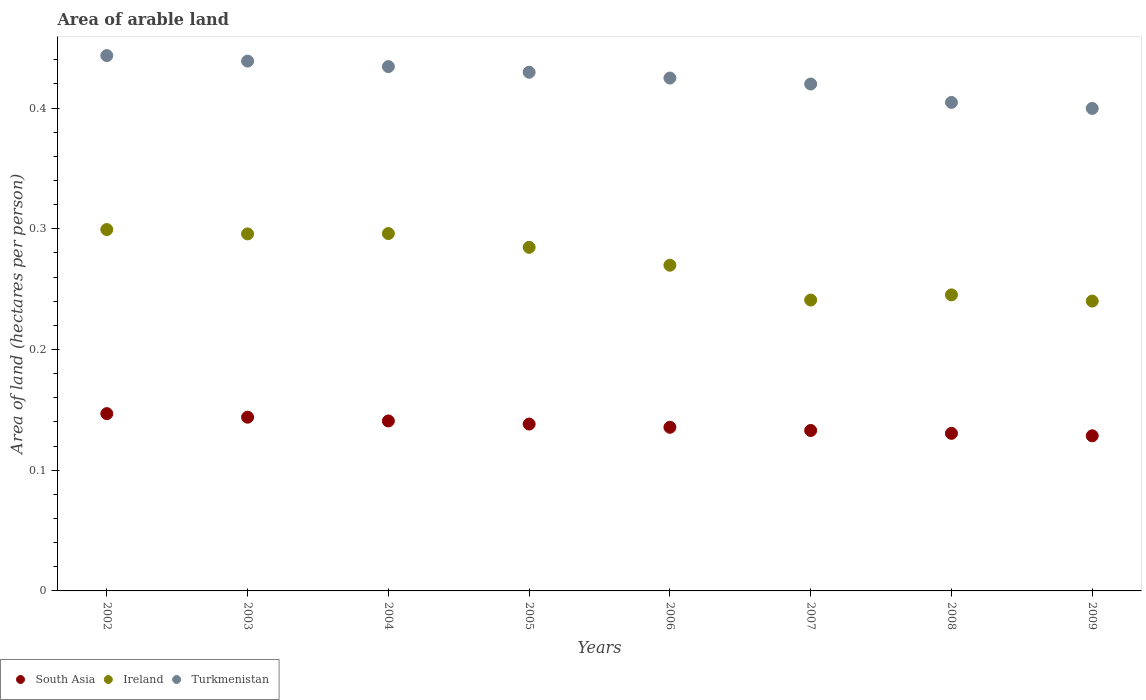What is the total arable land in Turkmenistan in 2007?
Offer a terse response. 0.42. Across all years, what is the maximum total arable land in Turkmenistan?
Offer a very short reply. 0.44. Across all years, what is the minimum total arable land in Ireland?
Give a very brief answer. 0.24. In which year was the total arable land in South Asia maximum?
Give a very brief answer. 2002. In which year was the total arable land in Turkmenistan minimum?
Provide a short and direct response. 2009. What is the total total arable land in Turkmenistan in the graph?
Give a very brief answer. 3.4. What is the difference between the total arable land in Ireland in 2004 and that in 2009?
Your answer should be very brief. 0.06. What is the difference between the total arable land in South Asia in 2004 and the total arable land in Turkmenistan in 2008?
Provide a succinct answer. -0.26. What is the average total arable land in Ireland per year?
Provide a short and direct response. 0.27. In the year 2008, what is the difference between the total arable land in South Asia and total arable land in Ireland?
Your answer should be compact. -0.11. In how many years, is the total arable land in South Asia greater than 0.34 hectares per person?
Offer a very short reply. 0. What is the ratio of the total arable land in Turkmenistan in 2006 to that in 2008?
Your answer should be compact. 1.05. Is the difference between the total arable land in South Asia in 2004 and 2009 greater than the difference between the total arable land in Ireland in 2004 and 2009?
Make the answer very short. No. What is the difference between the highest and the second highest total arable land in South Asia?
Offer a very short reply. 0. What is the difference between the highest and the lowest total arable land in Turkmenistan?
Your response must be concise. 0.04. In how many years, is the total arable land in South Asia greater than the average total arable land in South Asia taken over all years?
Your answer should be compact. 4. Is the sum of the total arable land in Ireland in 2004 and 2006 greater than the maximum total arable land in Turkmenistan across all years?
Your answer should be very brief. Yes. Is it the case that in every year, the sum of the total arable land in South Asia and total arable land in Ireland  is greater than the total arable land in Turkmenistan?
Provide a short and direct response. No. Is the total arable land in Turkmenistan strictly less than the total arable land in Ireland over the years?
Ensure brevity in your answer.  No. How many years are there in the graph?
Offer a very short reply. 8. Does the graph contain grids?
Offer a very short reply. No. What is the title of the graph?
Your answer should be compact. Area of arable land. What is the label or title of the X-axis?
Provide a short and direct response. Years. What is the label or title of the Y-axis?
Provide a succinct answer. Area of land (hectares per person). What is the Area of land (hectares per person) in South Asia in 2002?
Your response must be concise. 0.15. What is the Area of land (hectares per person) in Ireland in 2002?
Give a very brief answer. 0.3. What is the Area of land (hectares per person) of Turkmenistan in 2002?
Provide a succinct answer. 0.44. What is the Area of land (hectares per person) of South Asia in 2003?
Ensure brevity in your answer.  0.14. What is the Area of land (hectares per person) in Ireland in 2003?
Give a very brief answer. 0.3. What is the Area of land (hectares per person) in Turkmenistan in 2003?
Your answer should be compact. 0.44. What is the Area of land (hectares per person) in South Asia in 2004?
Offer a terse response. 0.14. What is the Area of land (hectares per person) in Ireland in 2004?
Provide a succinct answer. 0.3. What is the Area of land (hectares per person) of Turkmenistan in 2004?
Your response must be concise. 0.43. What is the Area of land (hectares per person) of South Asia in 2005?
Your answer should be compact. 0.14. What is the Area of land (hectares per person) in Ireland in 2005?
Offer a very short reply. 0.28. What is the Area of land (hectares per person) in Turkmenistan in 2005?
Your answer should be very brief. 0.43. What is the Area of land (hectares per person) in South Asia in 2006?
Give a very brief answer. 0.14. What is the Area of land (hectares per person) of Ireland in 2006?
Provide a succinct answer. 0.27. What is the Area of land (hectares per person) in Turkmenistan in 2006?
Provide a short and direct response. 0.42. What is the Area of land (hectares per person) of South Asia in 2007?
Your response must be concise. 0.13. What is the Area of land (hectares per person) in Ireland in 2007?
Your response must be concise. 0.24. What is the Area of land (hectares per person) of Turkmenistan in 2007?
Your response must be concise. 0.42. What is the Area of land (hectares per person) of South Asia in 2008?
Your answer should be very brief. 0.13. What is the Area of land (hectares per person) in Ireland in 2008?
Ensure brevity in your answer.  0.25. What is the Area of land (hectares per person) of Turkmenistan in 2008?
Your answer should be compact. 0.4. What is the Area of land (hectares per person) of South Asia in 2009?
Offer a terse response. 0.13. What is the Area of land (hectares per person) in Ireland in 2009?
Ensure brevity in your answer.  0.24. What is the Area of land (hectares per person) in Turkmenistan in 2009?
Ensure brevity in your answer.  0.4. Across all years, what is the maximum Area of land (hectares per person) in South Asia?
Ensure brevity in your answer.  0.15. Across all years, what is the maximum Area of land (hectares per person) of Ireland?
Your response must be concise. 0.3. Across all years, what is the maximum Area of land (hectares per person) in Turkmenistan?
Make the answer very short. 0.44. Across all years, what is the minimum Area of land (hectares per person) in South Asia?
Offer a very short reply. 0.13. Across all years, what is the minimum Area of land (hectares per person) of Ireland?
Offer a very short reply. 0.24. Across all years, what is the minimum Area of land (hectares per person) in Turkmenistan?
Provide a succinct answer. 0.4. What is the total Area of land (hectares per person) in South Asia in the graph?
Give a very brief answer. 1.1. What is the total Area of land (hectares per person) in Ireland in the graph?
Your response must be concise. 2.17. What is the total Area of land (hectares per person) of Turkmenistan in the graph?
Your answer should be compact. 3.4. What is the difference between the Area of land (hectares per person) in South Asia in 2002 and that in 2003?
Give a very brief answer. 0. What is the difference between the Area of land (hectares per person) in Ireland in 2002 and that in 2003?
Your answer should be compact. 0. What is the difference between the Area of land (hectares per person) in Turkmenistan in 2002 and that in 2003?
Provide a short and direct response. 0. What is the difference between the Area of land (hectares per person) in South Asia in 2002 and that in 2004?
Offer a terse response. 0.01. What is the difference between the Area of land (hectares per person) in Ireland in 2002 and that in 2004?
Your answer should be compact. 0. What is the difference between the Area of land (hectares per person) in Turkmenistan in 2002 and that in 2004?
Your response must be concise. 0.01. What is the difference between the Area of land (hectares per person) in South Asia in 2002 and that in 2005?
Ensure brevity in your answer.  0.01. What is the difference between the Area of land (hectares per person) in Ireland in 2002 and that in 2005?
Provide a short and direct response. 0.01. What is the difference between the Area of land (hectares per person) in Turkmenistan in 2002 and that in 2005?
Give a very brief answer. 0.01. What is the difference between the Area of land (hectares per person) of South Asia in 2002 and that in 2006?
Give a very brief answer. 0.01. What is the difference between the Area of land (hectares per person) in Ireland in 2002 and that in 2006?
Give a very brief answer. 0.03. What is the difference between the Area of land (hectares per person) in Turkmenistan in 2002 and that in 2006?
Your answer should be very brief. 0.02. What is the difference between the Area of land (hectares per person) in South Asia in 2002 and that in 2007?
Offer a very short reply. 0.01. What is the difference between the Area of land (hectares per person) of Ireland in 2002 and that in 2007?
Offer a terse response. 0.06. What is the difference between the Area of land (hectares per person) in Turkmenistan in 2002 and that in 2007?
Provide a succinct answer. 0.02. What is the difference between the Area of land (hectares per person) in South Asia in 2002 and that in 2008?
Keep it short and to the point. 0.02. What is the difference between the Area of land (hectares per person) of Ireland in 2002 and that in 2008?
Your answer should be very brief. 0.05. What is the difference between the Area of land (hectares per person) of Turkmenistan in 2002 and that in 2008?
Offer a terse response. 0.04. What is the difference between the Area of land (hectares per person) of South Asia in 2002 and that in 2009?
Your response must be concise. 0.02. What is the difference between the Area of land (hectares per person) of Ireland in 2002 and that in 2009?
Provide a short and direct response. 0.06. What is the difference between the Area of land (hectares per person) of Turkmenistan in 2002 and that in 2009?
Make the answer very short. 0.04. What is the difference between the Area of land (hectares per person) in South Asia in 2003 and that in 2004?
Give a very brief answer. 0. What is the difference between the Area of land (hectares per person) in Ireland in 2003 and that in 2004?
Your answer should be compact. -0. What is the difference between the Area of land (hectares per person) of Turkmenistan in 2003 and that in 2004?
Keep it short and to the point. 0. What is the difference between the Area of land (hectares per person) of South Asia in 2003 and that in 2005?
Provide a short and direct response. 0.01. What is the difference between the Area of land (hectares per person) of Ireland in 2003 and that in 2005?
Ensure brevity in your answer.  0.01. What is the difference between the Area of land (hectares per person) of Turkmenistan in 2003 and that in 2005?
Keep it short and to the point. 0.01. What is the difference between the Area of land (hectares per person) in South Asia in 2003 and that in 2006?
Offer a terse response. 0.01. What is the difference between the Area of land (hectares per person) in Ireland in 2003 and that in 2006?
Provide a succinct answer. 0.03. What is the difference between the Area of land (hectares per person) of Turkmenistan in 2003 and that in 2006?
Ensure brevity in your answer.  0.01. What is the difference between the Area of land (hectares per person) of South Asia in 2003 and that in 2007?
Your response must be concise. 0.01. What is the difference between the Area of land (hectares per person) of Ireland in 2003 and that in 2007?
Ensure brevity in your answer.  0.05. What is the difference between the Area of land (hectares per person) of Turkmenistan in 2003 and that in 2007?
Your answer should be very brief. 0.02. What is the difference between the Area of land (hectares per person) of South Asia in 2003 and that in 2008?
Offer a terse response. 0.01. What is the difference between the Area of land (hectares per person) of Ireland in 2003 and that in 2008?
Offer a very short reply. 0.05. What is the difference between the Area of land (hectares per person) of Turkmenistan in 2003 and that in 2008?
Offer a very short reply. 0.03. What is the difference between the Area of land (hectares per person) of South Asia in 2003 and that in 2009?
Give a very brief answer. 0.02. What is the difference between the Area of land (hectares per person) of Ireland in 2003 and that in 2009?
Ensure brevity in your answer.  0.06. What is the difference between the Area of land (hectares per person) in Turkmenistan in 2003 and that in 2009?
Your answer should be compact. 0.04. What is the difference between the Area of land (hectares per person) in South Asia in 2004 and that in 2005?
Your response must be concise. 0. What is the difference between the Area of land (hectares per person) of Ireland in 2004 and that in 2005?
Keep it short and to the point. 0.01. What is the difference between the Area of land (hectares per person) in Turkmenistan in 2004 and that in 2005?
Your response must be concise. 0. What is the difference between the Area of land (hectares per person) of South Asia in 2004 and that in 2006?
Keep it short and to the point. 0.01. What is the difference between the Area of land (hectares per person) in Ireland in 2004 and that in 2006?
Your answer should be very brief. 0.03. What is the difference between the Area of land (hectares per person) in Turkmenistan in 2004 and that in 2006?
Keep it short and to the point. 0.01. What is the difference between the Area of land (hectares per person) of South Asia in 2004 and that in 2007?
Ensure brevity in your answer.  0.01. What is the difference between the Area of land (hectares per person) of Ireland in 2004 and that in 2007?
Make the answer very short. 0.06. What is the difference between the Area of land (hectares per person) of Turkmenistan in 2004 and that in 2007?
Offer a terse response. 0.01. What is the difference between the Area of land (hectares per person) in South Asia in 2004 and that in 2008?
Give a very brief answer. 0.01. What is the difference between the Area of land (hectares per person) in Ireland in 2004 and that in 2008?
Provide a short and direct response. 0.05. What is the difference between the Area of land (hectares per person) in Turkmenistan in 2004 and that in 2008?
Give a very brief answer. 0.03. What is the difference between the Area of land (hectares per person) in South Asia in 2004 and that in 2009?
Offer a terse response. 0.01. What is the difference between the Area of land (hectares per person) of Ireland in 2004 and that in 2009?
Give a very brief answer. 0.06. What is the difference between the Area of land (hectares per person) in Turkmenistan in 2004 and that in 2009?
Your answer should be compact. 0.03. What is the difference between the Area of land (hectares per person) of South Asia in 2005 and that in 2006?
Make the answer very short. 0. What is the difference between the Area of land (hectares per person) of Ireland in 2005 and that in 2006?
Your answer should be very brief. 0.01. What is the difference between the Area of land (hectares per person) of Turkmenistan in 2005 and that in 2006?
Your response must be concise. 0. What is the difference between the Area of land (hectares per person) of South Asia in 2005 and that in 2007?
Keep it short and to the point. 0.01. What is the difference between the Area of land (hectares per person) in Ireland in 2005 and that in 2007?
Offer a terse response. 0.04. What is the difference between the Area of land (hectares per person) of Turkmenistan in 2005 and that in 2007?
Ensure brevity in your answer.  0.01. What is the difference between the Area of land (hectares per person) of South Asia in 2005 and that in 2008?
Your answer should be compact. 0.01. What is the difference between the Area of land (hectares per person) of Ireland in 2005 and that in 2008?
Provide a short and direct response. 0.04. What is the difference between the Area of land (hectares per person) in Turkmenistan in 2005 and that in 2008?
Offer a terse response. 0.03. What is the difference between the Area of land (hectares per person) of South Asia in 2005 and that in 2009?
Offer a terse response. 0.01. What is the difference between the Area of land (hectares per person) of Ireland in 2005 and that in 2009?
Your answer should be very brief. 0.04. What is the difference between the Area of land (hectares per person) in Turkmenistan in 2005 and that in 2009?
Your answer should be compact. 0.03. What is the difference between the Area of land (hectares per person) of South Asia in 2006 and that in 2007?
Provide a succinct answer. 0. What is the difference between the Area of land (hectares per person) of Ireland in 2006 and that in 2007?
Make the answer very short. 0.03. What is the difference between the Area of land (hectares per person) in Turkmenistan in 2006 and that in 2007?
Your answer should be compact. 0.01. What is the difference between the Area of land (hectares per person) in South Asia in 2006 and that in 2008?
Ensure brevity in your answer.  0.01. What is the difference between the Area of land (hectares per person) in Ireland in 2006 and that in 2008?
Your answer should be compact. 0.02. What is the difference between the Area of land (hectares per person) in Turkmenistan in 2006 and that in 2008?
Keep it short and to the point. 0.02. What is the difference between the Area of land (hectares per person) of South Asia in 2006 and that in 2009?
Your answer should be very brief. 0.01. What is the difference between the Area of land (hectares per person) in Ireland in 2006 and that in 2009?
Offer a terse response. 0.03. What is the difference between the Area of land (hectares per person) in Turkmenistan in 2006 and that in 2009?
Ensure brevity in your answer.  0.03. What is the difference between the Area of land (hectares per person) of South Asia in 2007 and that in 2008?
Ensure brevity in your answer.  0. What is the difference between the Area of land (hectares per person) of Ireland in 2007 and that in 2008?
Your answer should be compact. -0. What is the difference between the Area of land (hectares per person) of Turkmenistan in 2007 and that in 2008?
Keep it short and to the point. 0.02. What is the difference between the Area of land (hectares per person) in South Asia in 2007 and that in 2009?
Offer a terse response. 0. What is the difference between the Area of land (hectares per person) of Ireland in 2007 and that in 2009?
Your response must be concise. 0. What is the difference between the Area of land (hectares per person) of Turkmenistan in 2007 and that in 2009?
Give a very brief answer. 0.02. What is the difference between the Area of land (hectares per person) of South Asia in 2008 and that in 2009?
Ensure brevity in your answer.  0. What is the difference between the Area of land (hectares per person) in Ireland in 2008 and that in 2009?
Keep it short and to the point. 0.01. What is the difference between the Area of land (hectares per person) in Turkmenistan in 2008 and that in 2009?
Your answer should be compact. 0.01. What is the difference between the Area of land (hectares per person) of South Asia in 2002 and the Area of land (hectares per person) of Ireland in 2003?
Your answer should be compact. -0.15. What is the difference between the Area of land (hectares per person) of South Asia in 2002 and the Area of land (hectares per person) of Turkmenistan in 2003?
Make the answer very short. -0.29. What is the difference between the Area of land (hectares per person) in Ireland in 2002 and the Area of land (hectares per person) in Turkmenistan in 2003?
Provide a short and direct response. -0.14. What is the difference between the Area of land (hectares per person) of South Asia in 2002 and the Area of land (hectares per person) of Ireland in 2004?
Your response must be concise. -0.15. What is the difference between the Area of land (hectares per person) in South Asia in 2002 and the Area of land (hectares per person) in Turkmenistan in 2004?
Give a very brief answer. -0.29. What is the difference between the Area of land (hectares per person) in Ireland in 2002 and the Area of land (hectares per person) in Turkmenistan in 2004?
Provide a succinct answer. -0.14. What is the difference between the Area of land (hectares per person) in South Asia in 2002 and the Area of land (hectares per person) in Ireland in 2005?
Make the answer very short. -0.14. What is the difference between the Area of land (hectares per person) of South Asia in 2002 and the Area of land (hectares per person) of Turkmenistan in 2005?
Ensure brevity in your answer.  -0.28. What is the difference between the Area of land (hectares per person) in Ireland in 2002 and the Area of land (hectares per person) in Turkmenistan in 2005?
Ensure brevity in your answer.  -0.13. What is the difference between the Area of land (hectares per person) in South Asia in 2002 and the Area of land (hectares per person) in Ireland in 2006?
Provide a succinct answer. -0.12. What is the difference between the Area of land (hectares per person) in South Asia in 2002 and the Area of land (hectares per person) in Turkmenistan in 2006?
Ensure brevity in your answer.  -0.28. What is the difference between the Area of land (hectares per person) in Ireland in 2002 and the Area of land (hectares per person) in Turkmenistan in 2006?
Provide a succinct answer. -0.13. What is the difference between the Area of land (hectares per person) in South Asia in 2002 and the Area of land (hectares per person) in Ireland in 2007?
Your answer should be compact. -0.09. What is the difference between the Area of land (hectares per person) of South Asia in 2002 and the Area of land (hectares per person) of Turkmenistan in 2007?
Offer a terse response. -0.27. What is the difference between the Area of land (hectares per person) in Ireland in 2002 and the Area of land (hectares per person) in Turkmenistan in 2007?
Provide a succinct answer. -0.12. What is the difference between the Area of land (hectares per person) of South Asia in 2002 and the Area of land (hectares per person) of Ireland in 2008?
Your response must be concise. -0.1. What is the difference between the Area of land (hectares per person) in South Asia in 2002 and the Area of land (hectares per person) in Turkmenistan in 2008?
Your answer should be compact. -0.26. What is the difference between the Area of land (hectares per person) of Ireland in 2002 and the Area of land (hectares per person) of Turkmenistan in 2008?
Your response must be concise. -0.11. What is the difference between the Area of land (hectares per person) in South Asia in 2002 and the Area of land (hectares per person) in Ireland in 2009?
Your answer should be compact. -0.09. What is the difference between the Area of land (hectares per person) of South Asia in 2002 and the Area of land (hectares per person) of Turkmenistan in 2009?
Give a very brief answer. -0.25. What is the difference between the Area of land (hectares per person) of Ireland in 2002 and the Area of land (hectares per person) of Turkmenistan in 2009?
Provide a short and direct response. -0.1. What is the difference between the Area of land (hectares per person) of South Asia in 2003 and the Area of land (hectares per person) of Ireland in 2004?
Your answer should be compact. -0.15. What is the difference between the Area of land (hectares per person) in South Asia in 2003 and the Area of land (hectares per person) in Turkmenistan in 2004?
Keep it short and to the point. -0.29. What is the difference between the Area of land (hectares per person) of Ireland in 2003 and the Area of land (hectares per person) of Turkmenistan in 2004?
Your answer should be very brief. -0.14. What is the difference between the Area of land (hectares per person) of South Asia in 2003 and the Area of land (hectares per person) of Ireland in 2005?
Make the answer very short. -0.14. What is the difference between the Area of land (hectares per person) in South Asia in 2003 and the Area of land (hectares per person) in Turkmenistan in 2005?
Provide a short and direct response. -0.29. What is the difference between the Area of land (hectares per person) in Ireland in 2003 and the Area of land (hectares per person) in Turkmenistan in 2005?
Keep it short and to the point. -0.13. What is the difference between the Area of land (hectares per person) in South Asia in 2003 and the Area of land (hectares per person) in Ireland in 2006?
Your answer should be compact. -0.13. What is the difference between the Area of land (hectares per person) in South Asia in 2003 and the Area of land (hectares per person) in Turkmenistan in 2006?
Your response must be concise. -0.28. What is the difference between the Area of land (hectares per person) of Ireland in 2003 and the Area of land (hectares per person) of Turkmenistan in 2006?
Ensure brevity in your answer.  -0.13. What is the difference between the Area of land (hectares per person) in South Asia in 2003 and the Area of land (hectares per person) in Ireland in 2007?
Your answer should be very brief. -0.1. What is the difference between the Area of land (hectares per person) in South Asia in 2003 and the Area of land (hectares per person) in Turkmenistan in 2007?
Provide a short and direct response. -0.28. What is the difference between the Area of land (hectares per person) of Ireland in 2003 and the Area of land (hectares per person) of Turkmenistan in 2007?
Your answer should be very brief. -0.12. What is the difference between the Area of land (hectares per person) in South Asia in 2003 and the Area of land (hectares per person) in Ireland in 2008?
Keep it short and to the point. -0.1. What is the difference between the Area of land (hectares per person) of South Asia in 2003 and the Area of land (hectares per person) of Turkmenistan in 2008?
Give a very brief answer. -0.26. What is the difference between the Area of land (hectares per person) of Ireland in 2003 and the Area of land (hectares per person) of Turkmenistan in 2008?
Offer a very short reply. -0.11. What is the difference between the Area of land (hectares per person) of South Asia in 2003 and the Area of land (hectares per person) of Ireland in 2009?
Offer a terse response. -0.1. What is the difference between the Area of land (hectares per person) in South Asia in 2003 and the Area of land (hectares per person) in Turkmenistan in 2009?
Give a very brief answer. -0.26. What is the difference between the Area of land (hectares per person) in Ireland in 2003 and the Area of land (hectares per person) in Turkmenistan in 2009?
Offer a terse response. -0.1. What is the difference between the Area of land (hectares per person) in South Asia in 2004 and the Area of land (hectares per person) in Ireland in 2005?
Offer a very short reply. -0.14. What is the difference between the Area of land (hectares per person) of South Asia in 2004 and the Area of land (hectares per person) of Turkmenistan in 2005?
Your response must be concise. -0.29. What is the difference between the Area of land (hectares per person) of Ireland in 2004 and the Area of land (hectares per person) of Turkmenistan in 2005?
Your answer should be very brief. -0.13. What is the difference between the Area of land (hectares per person) in South Asia in 2004 and the Area of land (hectares per person) in Ireland in 2006?
Your answer should be very brief. -0.13. What is the difference between the Area of land (hectares per person) in South Asia in 2004 and the Area of land (hectares per person) in Turkmenistan in 2006?
Ensure brevity in your answer.  -0.28. What is the difference between the Area of land (hectares per person) of Ireland in 2004 and the Area of land (hectares per person) of Turkmenistan in 2006?
Offer a very short reply. -0.13. What is the difference between the Area of land (hectares per person) in South Asia in 2004 and the Area of land (hectares per person) in Ireland in 2007?
Your response must be concise. -0.1. What is the difference between the Area of land (hectares per person) of South Asia in 2004 and the Area of land (hectares per person) of Turkmenistan in 2007?
Give a very brief answer. -0.28. What is the difference between the Area of land (hectares per person) in Ireland in 2004 and the Area of land (hectares per person) in Turkmenistan in 2007?
Give a very brief answer. -0.12. What is the difference between the Area of land (hectares per person) in South Asia in 2004 and the Area of land (hectares per person) in Ireland in 2008?
Your answer should be compact. -0.1. What is the difference between the Area of land (hectares per person) in South Asia in 2004 and the Area of land (hectares per person) in Turkmenistan in 2008?
Your answer should be very brief. -0.26. What is the difference between the Area of land (hectares per person) in Ireland in 2004 and the Area of land (hectares per person) in Turkmenistan in 2008?
Your response must be concise. -0.11. What is the difference between the Area of land (hectares per person) of South Asia in 2004 and the Area of land (hectares per person) of Ireland in 2009?
Give a very brief answer. -0.1. What is the difference between the Area of land (hectares per person) of South Asia in 2004 and the Area of land (hectares per person) of Turkmenistan in 2009?
Provide a succinct answer. -0.26. What is the difference between the Area of land (hectares per person) of Ireland in 2004 and the Area of land (hectares per person) of Turkmenistan in 2009?
Ensure brevity in your answer.  -0.1. What is the difference between the Area of land (hectares per person) of South Asia in 2005 and the Area of land (hectares per person) of Ireland in 2006?
Provide a short and direct response. -0.13. What is the difference between the Area of land (hectares per person) of South Asia in 2005 and the Area of land (hectares per person) of Turkmenistan in 2006?
Keep it short and to the point. -0.29. What is the difference between the Area of land (hectares per person) of Ireland in 2005 and the Area of land (hectares per person) of Turkmenistan in 2006?
Keep it short and to the point. -0.14. What is the difference between the Area of land (hectares per person) in South Asia in 2005 and the Area of land (hectares per person) in Ireland in 2007?
Keep it short and to the point. -0.1. What is the difference between the Area of land (hectares per person) in South Asia in 2005 and the Area of land (hectares per person) in Turkmenistan in 2007?
Your answer should be compact. -0.28. What is the difference between the Area of land (hectares per person) in Ireland in 2005 and the Area of land (hectares per person) in Turkmenistan in 2007?
Offer a terse response. -0.14. What is the difference between the Area of land (hectares per person) in South Asia in 2005 and the Area of land (hectares per person) in Ireland in 2008?
Offer a very short reply. -0.11. What is the difference between the Area of land (hectares per person) of South Asia in 2005 and the Area of land (hectares per person) of Turkmenistan in 2008?
Your answer should be very brief. -0.27. What is the difference between the Area of land (hectares per person) in Ireland in 2005 and the Area of land (hectares per person) in Turkmenistan in 2008?
Make the answer very short. -0.12. What is the difference between the Area of land (hectares per person) of South Asia in 2005 and the Area of land (hectares per person) of Ireland in 2009?
Your answer should be very brief. -0.1. What is the difference between the Area of land (hectares per person) of South Asia in 2005 and the Area of land (hectares per person) of Turkmenistan in 2009?
Your answer should be compact. -0.26. What is the difference between the Area of land (hectares per person) in Ireland in 2005 and the Area of land (hectares per person) in Turkmenistan in 2009?
Ensure brevity in your answer.  -0.12. What is the difference between the Area of land (hectares per person) of South Asia in 2006 and the Area of land (hectares per person) of Ireland in 2007?
Your response must be concise. -0.11. What is the difference between the Area of land (hectares per person) in South Asia in 2006 and the Area of land (hectares per person) in Turkmenistan in 2007?
Provide a succinct answer. -0.28. What is the difference between the Area of land (hectares per person) of Ireland in 2006 and the Area of land (hectares per person) of Turkmenistan in 2007?
Ensure brevity in your answer.  -0.15. What is the difference between the Area of land (hectares per person) in South Asia in 2006 and the Area of land (hectares per person) in Ireland in 2008?
Offer a very short reply. -0.11. What is the difference between the Area of land (hectares per person) of South Asia in 2006 and the Area of land (hectares per person) of Turkmenistan in 2008?
Provide a short and direct response. -0.27. What is the difference between the Area of land (hectares per person) in Ireland in 2006 and the Area of land (hectares per person) in Turkmenistan in 2008?
Your answer should be compact. -0.13. What is the difference between the Area of land (hectares per person) in South Asia in 2006 and the Area of land (hectares per person) in Ireland in 2009?
Your response must be concise. -0.1. What is the difference between the Area of land (hectares per person) of South Asia in 2006 and the Area of land (hectares per person) of Turkmenistan in 2009?
Offer a very short reply. -0.26. What is the difference between the Area of land (hectares per person) in Ireland in 2006 and the Area of land (hectares per person) in Turkmenistan in 2009?
Your answer should be compact. -0.13. What is the difference between the Area of land (hectares per person) of South Asia in 2007 and the Area of land (hectares per person) of Ireland in 2008?
Your response must be concise. -0.11. What is the difference between the Area of land (hectares per person) of South Asia in 2007 and the Area of land (hectares per person) of Turkmenistan in 2008?
Your answer should be very brief. -0.27. What is the difference between the Area of land (hectares per person) of Ireland in 2007 and the Area of land (hectares per person) of Turkmenistan in 2008?
Your response must be concise. -0.16. What is the difference between the Area of land (hectares per person) of South Asia in 2007 and the Area of land (hectares per person) of Ireland in 2009?
Your response must be concise. -0.11. What is the difference between the Area of land (hectares per person) of South Asia in 2007 and the Area of land (hectares per person) of Turkmenistan in 2009?
Offer a terse response. -0.27. What is the difference between the Area of land (hectares per person) in Ireland in 2007 and the Area of land (hectares per person) in Turkmenistan in 2009?
Give a very brief answer. -0.16. What is the difference between the Area of land (hectares per person) in South Asia in 2008 and the Area of land (hectares per person) in Ireland in 2009?
Give a very brief answer. -0.11. What is the difference between the Area of land (hectares per person) of South Asia in 2008 and the Area of land (hectares per person) of Turkmenistan in 2009?
Your answer should be very brief. -0.27. What is the difference between the Area of land (hectares per person) of Ireland in 2008 and the Area of land (hectares per person) of Turkmenistan in 2009?
Make the answer very short. -0.15. What is the average Area of land (hectares per person) of South Asia per year?
Offer a terse response. 0.14. What is the average Area of land (hectares per person) in Ireland per year?
Make the answer very short. 0.27. What is the average Area of land (hectares per person) of Turkmenistan per year?
Offer a terse response. 0.42. In the year 2002, what is the difference between the Area of land (hectares per person) of South Asia and Area of land (hectares per person) of Ireland?
Make the answer very short. -0.15. In the year 2002, what is the difference between the Area of land (hectares per person) in South Asia and Area of land (hectares per person) in Turkmenistan?
Provide a succinct answer. -0.3. In the year 2002, what is the difference between the Area of land (hectares per person) of Ireland and Area of land (hectares per person) of Turkmenistan?
Offer a very short reply. -0.14. In the year 2003, what is the difference between the Area of land (hectares per person) in South Asia and Area of land (hectares per person) in Ireland?
Give a very brief answer. -0.15. In the year 2003, what is the difference between the Area of land (hectares per person) of South Asia and Area of land (hectares per person) of Turkmenistan?
Offer a very short reply. -0.29. In the year 2003, what is the difference between the Area of land (hectares per person) of Ireland and Area of land (hectares per person) of Turkmenistan?
Make the answer very short. -0.14. In the year 2004, what is the difference between the Area of land (hectares per person) of South Asia and Area of land (hectares per person) of Ireland?
Your answer should be compact. -0.16. In the year 2004, what is the difference between the Area of land (hectares per person) in South Asia and Area of land (hectares per person) in Turkmenistan?
Your answer should be very brief. -0.29. In the year 2004, what is the difference between the Area of land (hectares per person) of Ireland and Area of land (hectares per person) of Turkmenistan?
Offer a very short reply. -0.14. In the year 2005, what is the difference between the Area of land (hectares per person) of South Asia and Area of land (hectares per person) of Ireland?
Provide a succinct answer. -0.15. In the year 2005, what is the difference between the Area of land (hectares per person) of South Asia and Area of land (hectares per person) of Turkmenistan?
Keep it short and to the point. -0.29. In the year 2005, what is the difference between the Area of land (hectares per person) of Ireland and Area of land (hectares per person) of Turkmenistan?
Your response must be concise. -0.14. In the year 2006, what is the difference between the Area of land (hectares per person) of South Asia and Area of land (hectares per person) of Ireland?
Your answer should be very brief. -0.13. In the year 2006, what is the difference between the Area of land (hectares per person) of South Asia and Area of land (hectares per person) of Turkmenistan?
Provide a succinct answer. -0.29. In the year 2006, what is the difference between the Area of land (hectares per person) in Ireland and Area of land (hectares per person) in Turkmenistan?
Offer a terse response. -0.16. In the year 2007, what is the difference between the Area of land (hectares per person) in South Asia and Area of land (hectares per person) in Ireland?
Ensure brevity in your answer.  -0.11. In the year 2007, what is the difference between the Area of land (hectares per person) in South Asia and Area of land (hectares per person) in Turkmenistan?
Your answer should be very brief. -0.29. In the year 2007, what is the difference between the Area of land (hectares per person) in Ireland and Area of land (hectares per person) in Turkmenistan?
Provide a succinct answer. -0.18. In the year 2008, what is the difference between the Area of land (hectares per person) in South Asia and Area of land (hectares per person) in Ireland?
Ensure brevity in your answer.  -0.11. In the year 2008, what is the difference between the Area of land (hectares per person) of South Asia and Area of land (hectares per person) of Turkmenistan?
Provide a short and direct response. -0.27. In the year 2008, what is the difference between the Area of land (hectares per person) of Ireland and Area of land (hectares per person) of Turkmenistan?
Provide a succinct answer. -0.16. In the year 2009, what is the difference between the Area of land (hectares per person) in South Asia and Area of land (hectares per person) in Ireland?
Make the answer very short. -0.11. In the year 2009, what is the difference between the Area of land (hectares per person) in South Asia and Area of land (hectares per person) in Turkmenistan?
Make the answer very short. -0.27. In the year 2009, what is the difference between the Area of land (hectares per person) in Ireland and Area of land (hectares per person) in Turkmenistan?
Provide a succinct answer. -0.16. What is the ratio of the Area of land (hectares per person) in South Asia in 2002 to that in 2003?
Keep it short and to the point. 1.02. What is the ratio of the Area of land (hectares per person) of Ireland in 2002 to that in 2003?
Make the answer very short. 1.01. What is the ratio of the Area of land (hectares per person) of Turkmenistan in 2002 to that in 2003?
Provide a succinct answer. 1.01. What is the ratio of the Area of land (hectares per person) in South Asia in 2002 to that in 2004?
Provide a succinct answer. 1.04. What is the ratio of the Area of land (hectares per person) in Ireland in 2002 to that in 2004?
Offer a terse response. 1.01. What is the ratio of the Area of land (hectares per person) in South Asia in 2002 to that in 2005?
Your response must be concise. 1.06. What is the ratio of the Area of land (hectares per person) of Ireland in 2002 to that in 2005?
Your response must be concise. 1.05. What is the ratio of the Area of land (hectares per person) in Turkmenistan in 2002 to that in 2005?
Ensure brevity in your answer.  1.03. What is the ratio of the Area of land (hectares per person) of South Asia in 2002 to that in 2006?
Your answer should be very brief. 1.08. What is the ratio of the Area of land (hectares per person) of Ireland in 2002 to that in 2006?
Your answer should be compact. 1.11. What is the ratio of the Area of land (hectares per person) in Turkmenistan in 2002 to that in 2006?
Ensure brevity in your answer.  1.04. What is the ratio of the Area of land (hectares per person) of South Asia in 2002 to that in 2007?
Provide a short and direct response. 1.11. What is the ratio of the Area of land (hectares per person) of Ireland in 2002 to that in 2007?
Ensure brevity in your answer.  1.24. What is the ratio of the Area of land (hectares per person) in Turkmenistan in 2002 to that in 2007?
Your answer should be very brief. 1.06. What is the ratio of the Area of land (hectares per person) of South Asia in 2002 to that in 2008?
Your answer should be very brief. 1.13. What is the ratio of the Area of land (hectares per person) in Ireland in 2002 to that in 2008?
Give a very brief answer. 1.22. What is the ratio of the Area of land (hectares per person) in Turkmenistan in 2002 to that in 2008?
Offer a very short reply. 1.1. What is the ratio of the Area of land (hectares per person) of South Asia in 2002 to that in 2009?
Ensure brevity in your answer.  1.14. What is the ratio of the Area of land (hectares per person) of Ireland in 2002 to that in 2009?
Your response must be concise. 1.25. What is the ratio of the Area of land (hectares per person) in Turkmenistan in 2002 to that in 2009?
Offer a terse response. 1.11. What is the ratio of the Area of land (hectares per person) of South Asia in 2003 to that in 2004?
Keep it short and to the point. 1.02. What is the ratio of the Area of land (hectares per person) of Turkmenistan in 2003 to that in 2004?
Provide a succinct answer. 1.01. What is the ratio of the Area of land (hectares per person) of South Asia in 2003 to that in 2005?
Offer a terse response. 1.04. What is the ratio of the Area of land (hectares per person) in Ireland in 2003 to that in 2005?
Offer a very short reply. 1.04. What is the ratio of the Area of land (hectares per person) of Turkmenistan in 2003 to that in 2005?
Provide a succinct answer. 1.02. What is the ratio of the Area of land (hectares per person) in South Asia in 2003 to that in 2006?
Offer a very short reply. 1.06. What is the ratio of the Area of land (hectares per person) in Ireland in 2003 to that in 2006?
Make the answer very short. 1.1. What is the ratio of the Area of land (hectares per person) of Turkmenistan in 2003 to that in 2006?
Keep it short and to the point. 1.03. What is the ratio of the Area of land (hectares per person) of South Asia in 2003 to that in 2007?
Your answer should be very brief. 1.08. What is the ratio of the Area of land (hectares per person) in Ireland in 2003 to that in 2007?
Give a very brief answer. 1.23. What is the ratio of the Area of land (hectares per person) in Turkmenistan in 2003 to that in 2007?
Offer a very short reply. 1.05. What is the ratio of the Area of land (hectares per person) in South Asia in 2003 to that in 2008?
Keep it short and to the point. 1.1. What is the ratio of the Area of land (hectares per person) in Ireland in 2003 to that in 2008?
Ensure brevity in your answer.  1.21. What is the ratio of the Area of land (hectares per person) in Turkmenistan in 2003 to that in 2008?
Your response must be concise. 1.08. What is the ratio of the Area of land (hectares per person) of South Asia in 2003 to that in 2009?
Offer a very short reply. 1.12. What is the ratio of the Area of land (hectares per person) of Ireland in 2003 to that in 2009?
Keep it short and to the point. 1.23. What is the ratio of the Area of land (hectares per person) of Turkmenistan in 2003 to that in 2009?
Keep it short and to the point. 1.1. What is the ratio of the Area of land (hectares per person) of South Asia in 2004 to that in 2005?
Keep it short and to the point. 1.02. What is the ratio of the Area of land (hectares per person) of Ireland in 2004 to that in 2005?
Your response must be concise. 1.04. What is the ratio of the Area of land (hectares per person) in Turkmenistan in 2004 to that in 2005?
Give a very brief answer. 1.01. What is the ratio of the Area of land (hectares per person) of South Asia in 2004 to that in 2006?
Make the answer very short. 1.04. What is the ratio of the Area of land (hectares per person) in Ireland in 2004 to that in 2006?
Your response must be concise. 1.1. What is the ratio of the Area of land (hectares per person) in Turkmenistan in 2004 to that in 2006?
Give a very brief answer. 1.02. What is the ratio of the Area of land (hectares per person) of South Asia in 2004 to that in 2007?
Keep it short and to the point. 1.06. What is the ratio of the Area of land (hectares per person) of Ireland in 2004 to that in 2007?
Offer a terse response. 1.23. What is the ratio of the Area of land (hectares per person) of Turkmenistan in 2004 to that in 2007?
Keep it short and to the point. 1.03. What is the ratio of the Area of land (hectares per person) of South Asia in 2004 to that in 2008?
Keep it short and to the point. 1.08. What is the ratio of the Area of land (hectares per person) of Ireland in 2004 to that in 2008?
Offer a very short reply. 1.21. What is the ratio of the Area of land (hectares per person) in Turkmenistan in 2004 to that in 2008?
Make the answer very short. 1.07. What is the ratio of the Area of land (hectares per person) in South Asia in 2004 to that in 2009?
Keep it short and to the point. 1.1. What is the ratio of the Area of land (hectares per person) of Ireland in 2004 to that in 2009?
Your response must be concise. 1.23. What is the ratio of the Area of land (hectares per person) of Turkmenistan in 2004 to that in 2009?
Give a very brief answer. 1.09. What is the ratio of the Area of land (hectares per person) of South Asia in 2005 to that in 2006?
Keep it short and to the point. 1.02. What is the ratio of the Area of land (hectares per person) of Ireland in 2005 to that in 2006?
Your answer should be very brief. 1.05. What is the ratio of the Area of land (hectares per person) of Turkmenistan in 2005 to that in 2006?
Your answer should be compact. 1.01. What is the ratio of the Area of land (hectares per person) of South Asia in 2005 to that in 2007?
Your answer should be compact. 1.04. What is the ratio of the Area of land (hectares per person) of Ireland in 2005 to that in 2007?
Keep it short and to the point. 1.18. What is the ratio of the Area of land (hectares per person) of Turkmenistan in 2005 to that in 2007?
Keep it short and to the point. 1.02. What is the ratio of the Area of land (hectares per person) in South Asia in 2005 to that in 2008?
Keep it short and to the point. 1.06. What is the ratio of the Area of land (hectares per person) of Ireland in 2005 to that in 2008?
Keep it short and to the point. 1.16. What is the ratio of the Area of land (hectares per person) of Turkmenistan in 2005 to that in 2008?
Ensure brevity in your answer.  1.06. What is the ratio of the Area of land (hectares per person) in South Asia in 2005 to that in 2009?
Make the answer very short. 1.08. What is the ratio of the Area of land (hectares per person) of Ireland in 2005 to that in 2009?
Your answer should be compact. 1.19. What is the ratio of the Area of land (hectares per person) of Turkmenistan in 2005 to that in 2009?
Offer a very short reply. 1.07. What is the ratio of the Area of land (hectares per person) of Ireland in 2006 to that in 2007?
Ensure brevity in your answer.  1.12. What is the ratio of the Area of land (hectares per person) of Turkmenistan in 2006 to that in 2007?
Offer a very short reply. 1.01. What is the ratio of the Area of land (hectares per person) in South Asia in 2006 to that in 2008?
Your response must be concise. 1.04. What is the ratio of the Area of land (hectares per person) in Ireland in 2006 to that in 2008?
Provide a succinct answer. 1.1. What is the ratio of the Area of land (hectares per person) of Turkmenistan in 2006 to that in 2008?
Offer a very short reply. 1.05. What is the ratio of the Area of land (hectares per person) in South Asia in 2006 to that in 2009?
Make the answer very short. 1.05. What is the ratio of the Area of land (hectares per person) of Ireland in 2006 to that in 2009?
Make the answer very short. 1.12. What is the ratio of the Area of land (hectares per person) of Turkmenistan in 2006 to that in 2009?
Offer a terse response. 1.06. What is the ratio of the Area of land (hectares per person) of South Asia in 2007 to that in 2008?
Make the answer very short. 1.02. What is the ratio of the Area of land (hectares per person) of Ireland in 2007 to that in 2008?
Offer a very short reply. 0.98. What is the ratio of the Area of land (hectares per person) in Turkmenistan in 2007 to that in 2008?
Offer a terse response. 1.04. What is the ratio of the Area of land (hectares per person) of South Asia in 2007 to that in 2009?
Ensure brevity in your answer.  1.03. What is the ratio of the Area of land (hectares per person) of Turkmenistan in 2007 to that in 2009?
Offer a terse response. 1.05. What is the ratio of the Area of land (hectares per person) of South Asia in 2008 to that in 2009?
Offer a very short reply. 1.02. What is the ratio of the Area of land (hectares per person) in Ireland in 2008 to that in 2009?
Offer a very short reply. 1.02. What is the ratio of the Area of land (hectares per person) in Turkmenistan in 2008 to that in 2009?
Provide a succinct answer. 1.01. What is the difference between the highest and the second highest Area of land (hectares per person) in South Asia?
Your response must be concise. 0. What is the difference between the highest and the second highest Area of land (hectares per person) in Ireland?
Provide a succinct answer. 0. What is the difference between the highest and the second highest Area of land (hectares per person) of Turkmenistan?
Your answer should be very brief. 0. What is the difference between the highest and the lowest Area of land (hectares per person) of South Asia?
Your answer should be compact. 0.02. What is the difference between the highest and the lowest Area of land (hectares per person) of Ireland?
Your answer should be compact. 0.06. What is the difference between the highest and the lowest Area of land (hectares per person) of Turkmenistan?
Give a very brief answer. 0.04. 